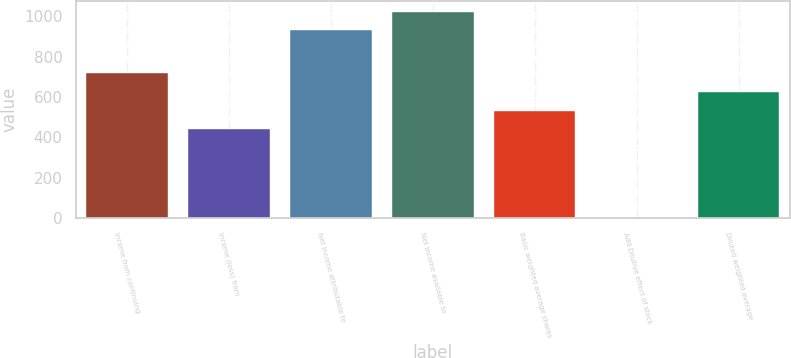<chart> <loc_0><loc_0><loc_500><loc_500><bar_chart><fcel>Income from continuing<fcel>Income (loss) from<fcel>Net income attributable to<fcel>Net income available to<fcel>Basic weighted average shares<fcel>Add Dilutive effect of stock<fcel>Diluted weighted average<nl><fcel>717.66<fcel>439.5<fcel>930.6<fcel>1023.32<fcel>532.22<fcel>3.4<fcel>624.94<nl></chart> 